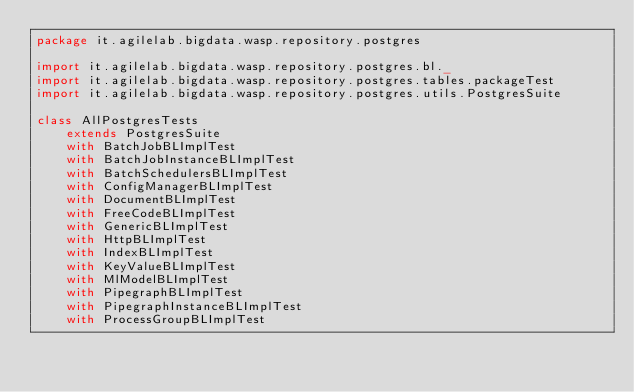Convert code to text. <code><loc_0><loc_0><loc_500><loc_500><_Scala_>package it.agilelab.bigdata.wasp.repository.postgres

import it.agilelab.bigdata.wasp.repository.postgres.bl._
import it.agilelab.bigdata.wasp.repository.postgres.tables.packageTest
import it.agilelab.bigdata.wasp.repository.postgres.utils.PostgresSuite

class AllPostgresTests
    extends PostgresSuite
    with BatchJobBLImplTest
    with BatchJobInstanceBLImplTest
    with BatchSchedulersBLImplTest
    with ConfigManagerBLImplTest
    with DocumentBLImplTest
    with FreeCodeBLImplTest
    with GenericBLImplTest
    with HttpBLImplTest
    with IndexBLImplTest
    with KeyValueBLImplTest
    with MlModelBLImplTest
    with PipegraphBLImplTest
    with PipegraphInstanceBLImplTest
    with ProcessGroupBLImplTest</code> 